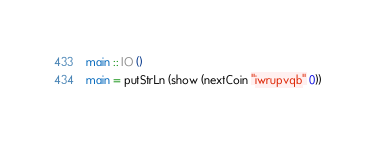Convert code to text. <code><loc_0><loc_0><loc_500><loc_500><_Haskell_>
main :: IO ()
main = putStrLn (show (nextCoin "iwrupvqb" 0))
</code> 